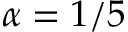Convert formula to latex. <formula><loc_0><loc_0><loc_500><loc_500>\alpha = 1 / 5</formula> 